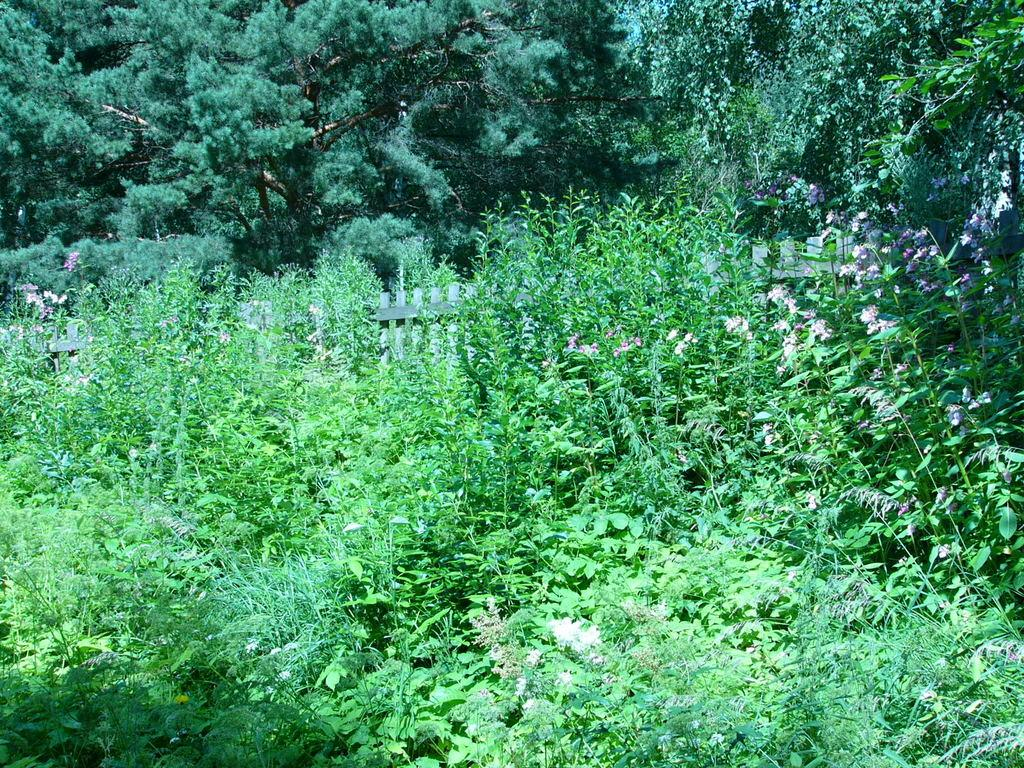What type of fencing is visible in the image? There is wooden fencing in the image. What natural elements can be seen in the image? There are trees and plants in the image. What type of protest is taking place in the image? There is no protest present in the image; it features wooden fencing, trees, and plants. Can you see any railway tracks in the image? There are no railway tracks present in the image. 